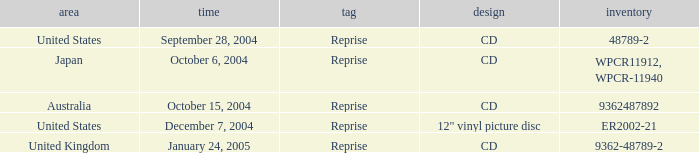Name the date that is a cd September 28, 2004, October 6, 2004, October 15, 2004, January 24, 2005. 